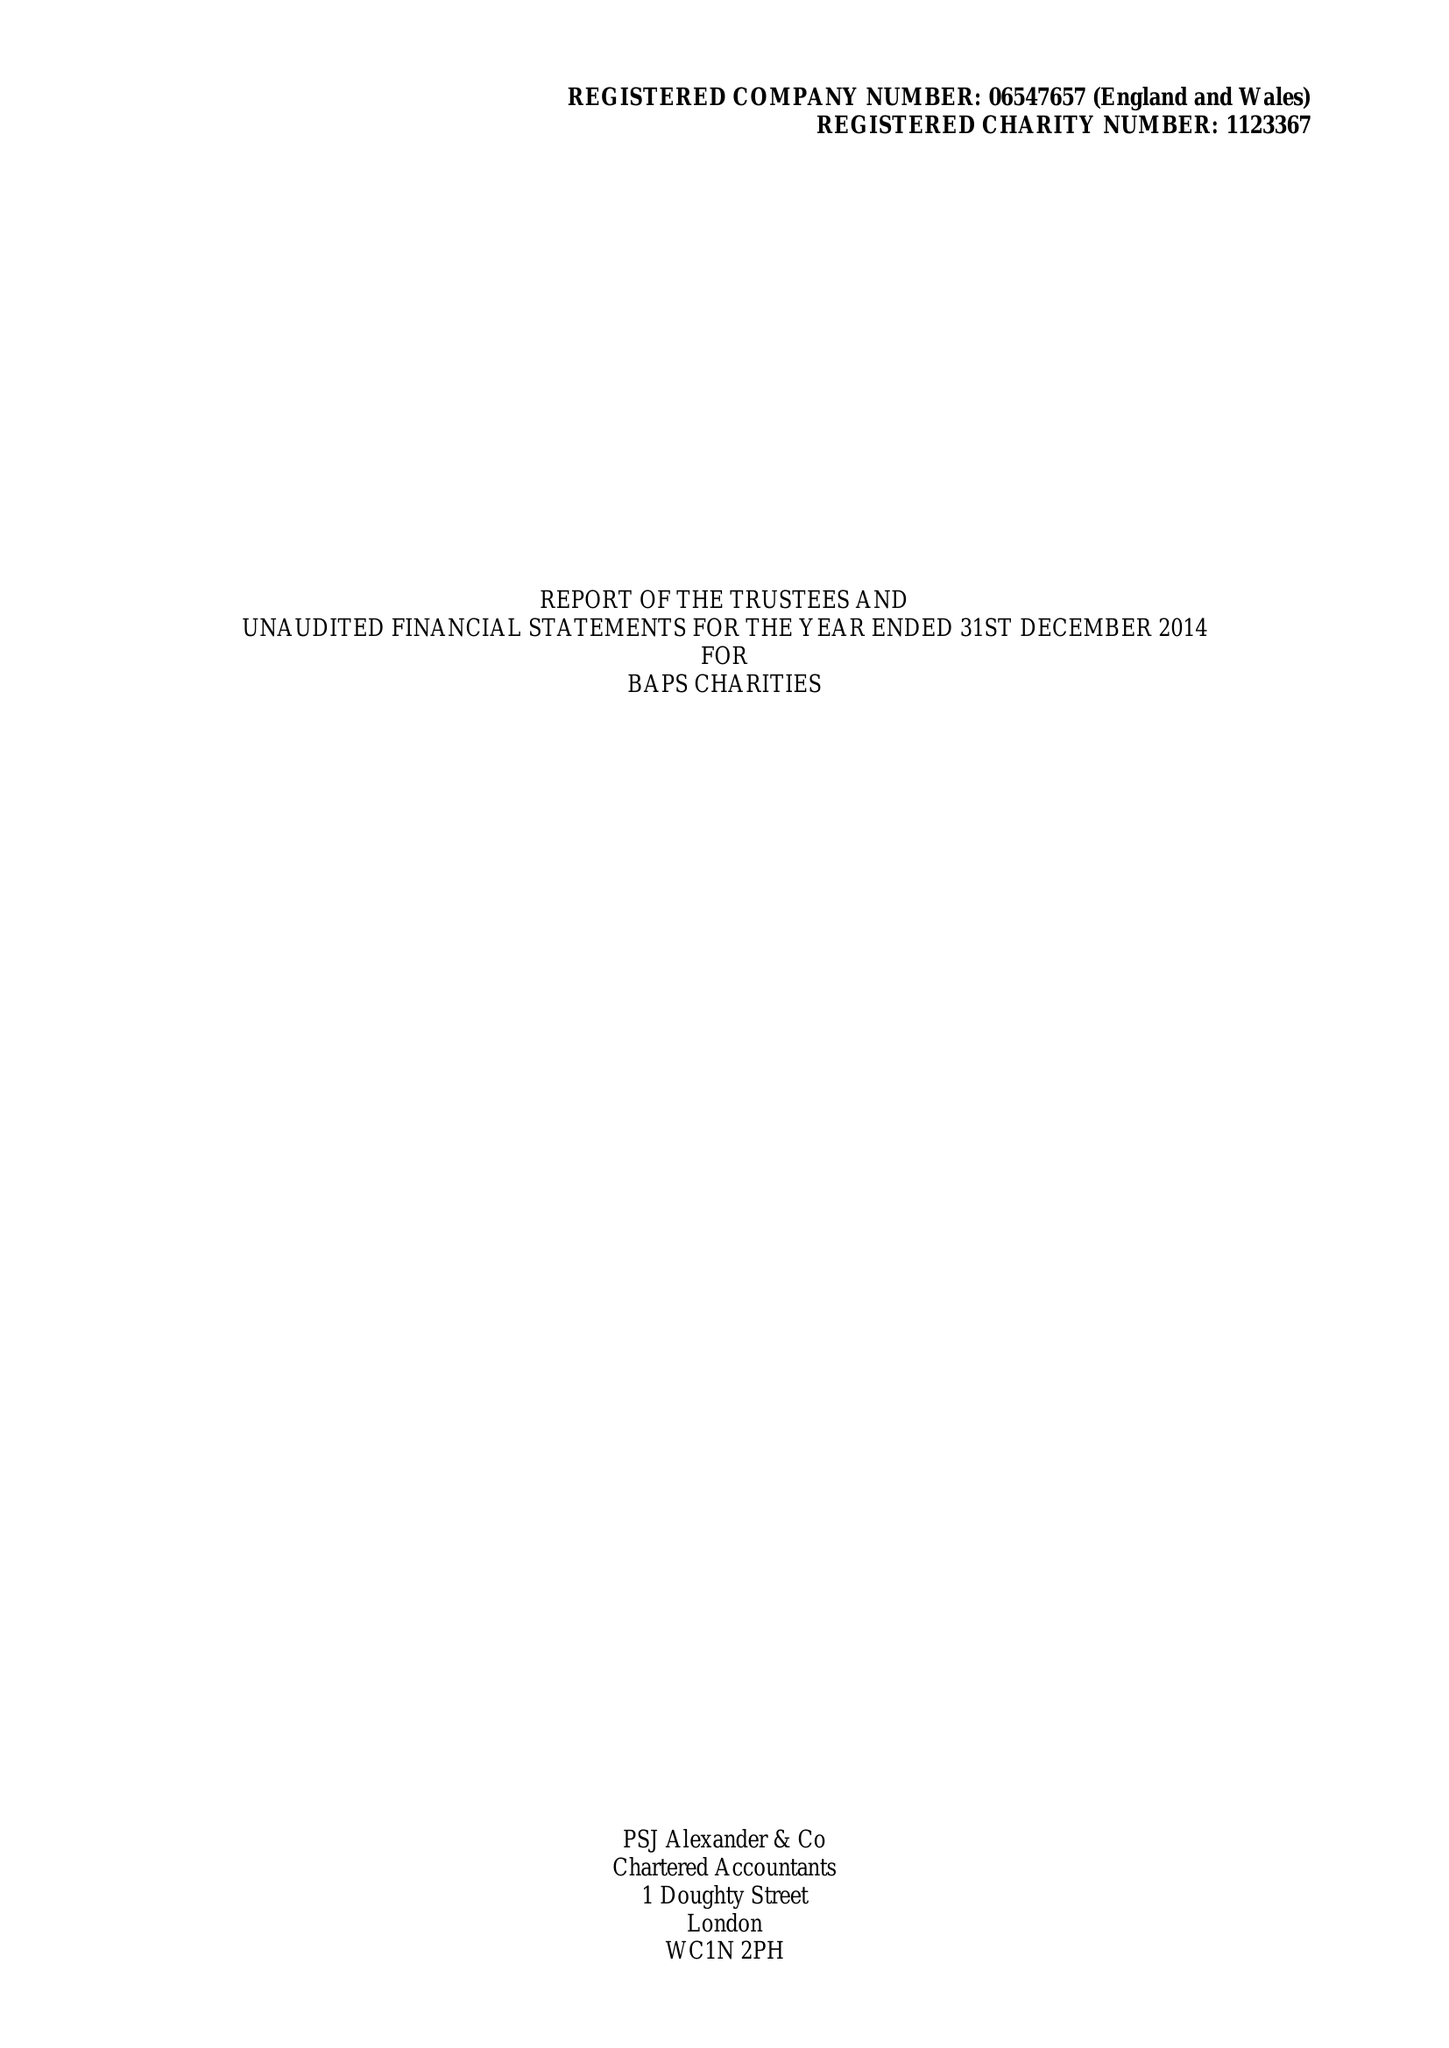What is the value for the income_annually_in_british_pounds?
Answer the question using a single word or phrase. 284171.00 